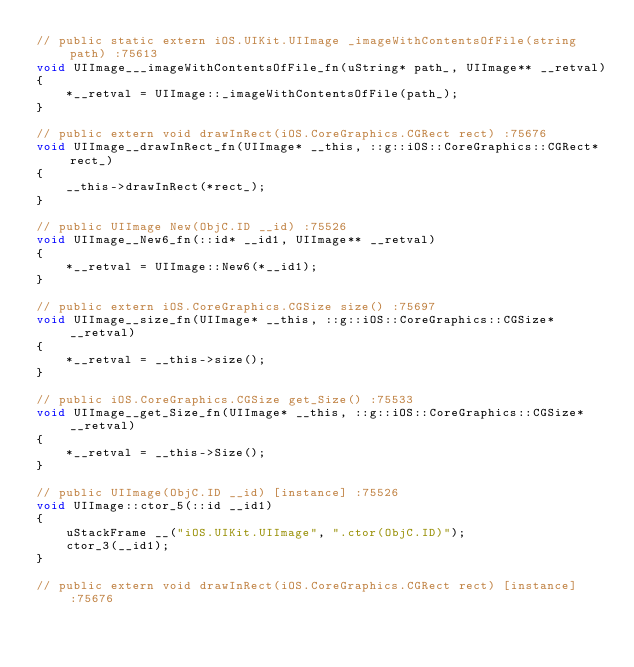<code> <loc_0><loc_0><loc_500><loc_500><_ObjectiveC_>// public static extern iOS.UIKit.UIImage _imageWithContentsOfFile(string path) :75613
void UIImage___imageWithContentsOfFile_fn(uString* path_, UIImage** __retval)
{
    *__retval = UIImage::_imageWithContentsOfFile(path_);
}

// public extern void drawInRect(iOS.CoreGraphics.CGRect rect) :75676
void UIImage__drawInRect_fn(UIImage* __this, ::g::iOS::CoreGraphics::CGRect* rect_)
{
    __this->drawInRect(*rect_);
}

// public UIImage New(ObjC.ID __id) :75526
void UIImage__New6_fn(::id* __id1, UIImage** __retval)
{
    *__retval = UIImage::New6(*__id1);
}

// public extern iOS.CoreGraphics.CGSize size() :75697
void UIImage__size_fn(UIImage* __this, ::g::iOS::CoreGraphics::CGSize* __retval)
{
    *__retval = __this->size();
}

// public iOS.CoreGraphics.CGSize get_Size() :75533
void UIImage__get_Size_fn(UIImage* __this, ::g::iOS::CoreGraphics::CGSize* __retval)
{
    *__retval = __this->Size();
}

// public UIImage(ObjC.ID __id) [instance] :75526
void UIImage::ctor_5(::id __id1)
{
    uStackFrame __("iOS.UIKit.UIImage", ".ctor(ObjC.ID)");
    ctor_3(__id1);
}

// public extern void drawInRect(iOS.CoreGraphics.CGRect rect) [instance] :75676</code> 